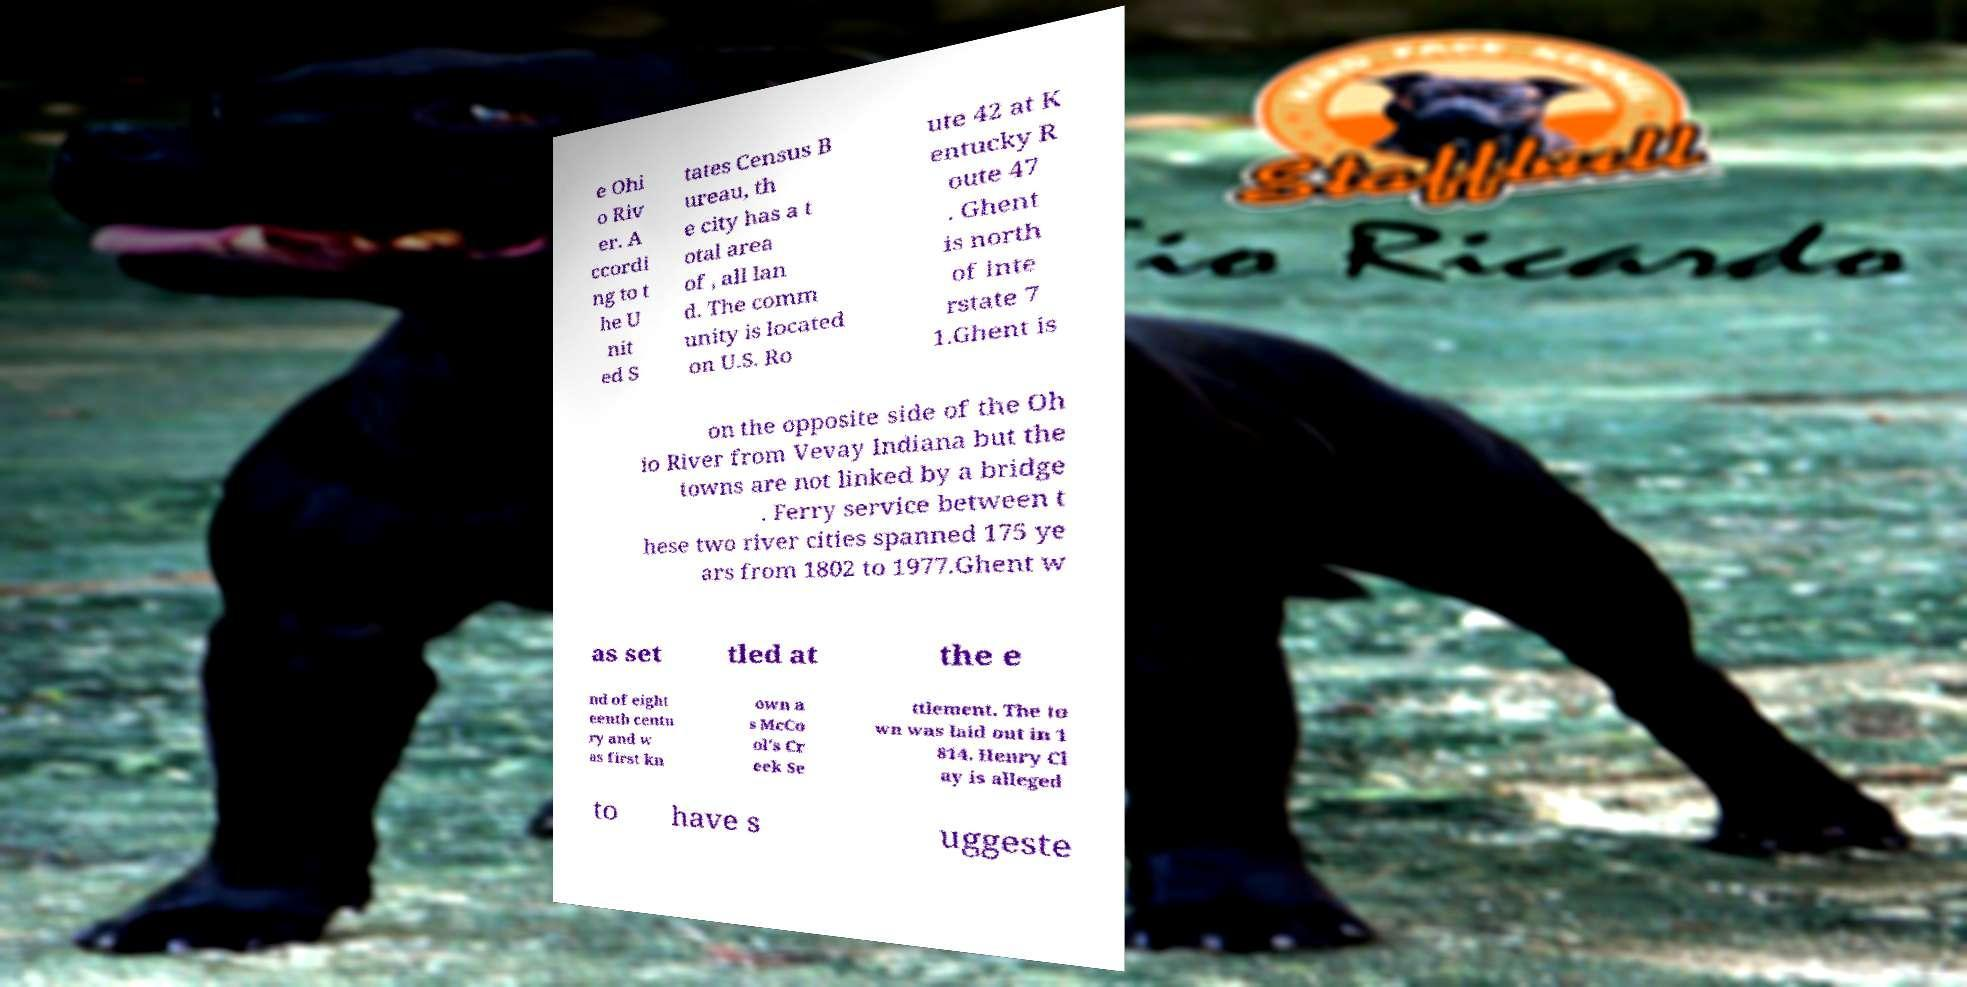Please identify and transcribe the text found in this image. e Ohi o Riv er. A ccordi ng to t he U nit ed S tates Census B ureau, th e city has a t otal area of , all lan d. The comm unity is located on U.S. Ro ute 42 at K entucky R oute 47 . Ghent is north of Inte rstate 7 1.Ghent is on the opposite side of the Oh io River from Vevay Indiana but the towns are not linked by a bridge . Ferry service between t hese two river cities spanned 175 ye ars from 1802 to 1977.Ghent w as set tled at the e nd of eight eenth centu ry and w as first kn own a s McCo ol's Cr eek Se ttlement. The to wn was laid out in 1 814. Henry Cl ay is alleged to have s uggeste 